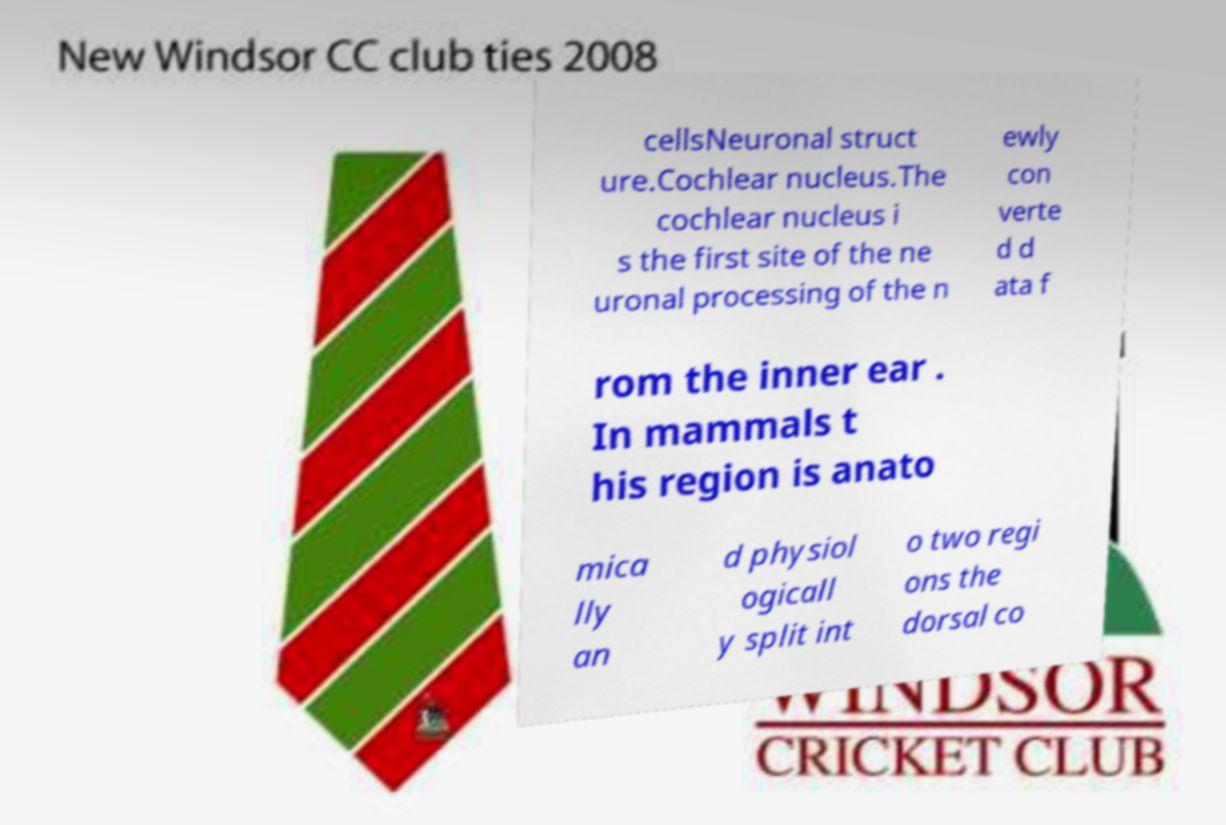What messages or text are displayed in this image? I need them in a readable, typed format. cellsNeuronal struct ure.Cochlear nucleus.The cochlear nucleus i s the first site of the ne uronal processing of the n ewly con verte d d ata f rom the inner ear . In mammals t his region is anato mica lly an d physiol ogicall y split int o two regi ons the dorsal co 